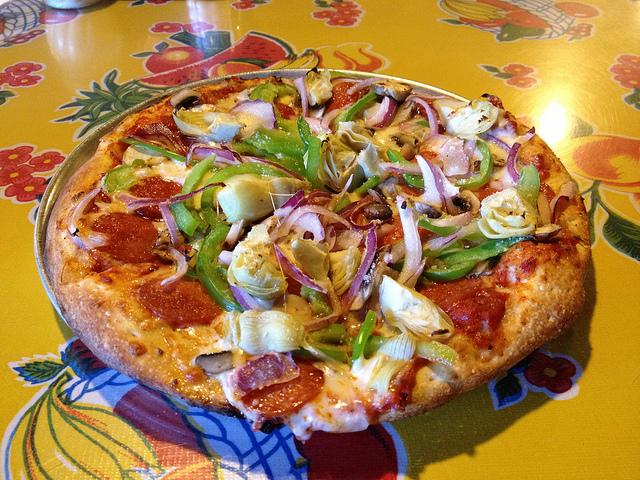What color is the tablecloth?
Be succinct. Yellow. Is this a vegetarian pizza?
Be succinct. No. What color is the table?
Keep it brief. Yellow. What food is pictured?
Give a very brief answer. Pizza. 